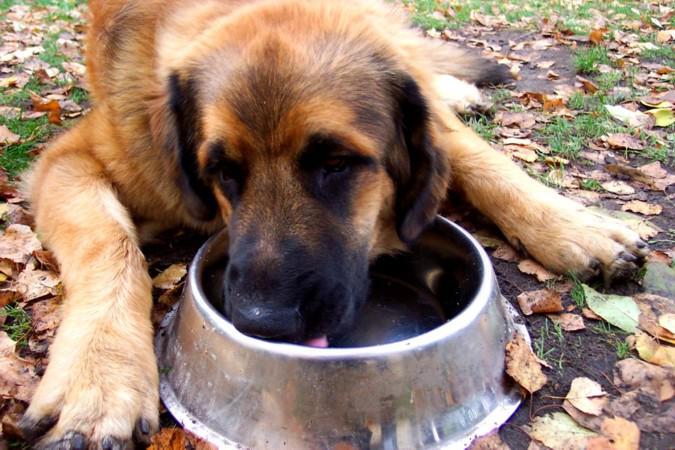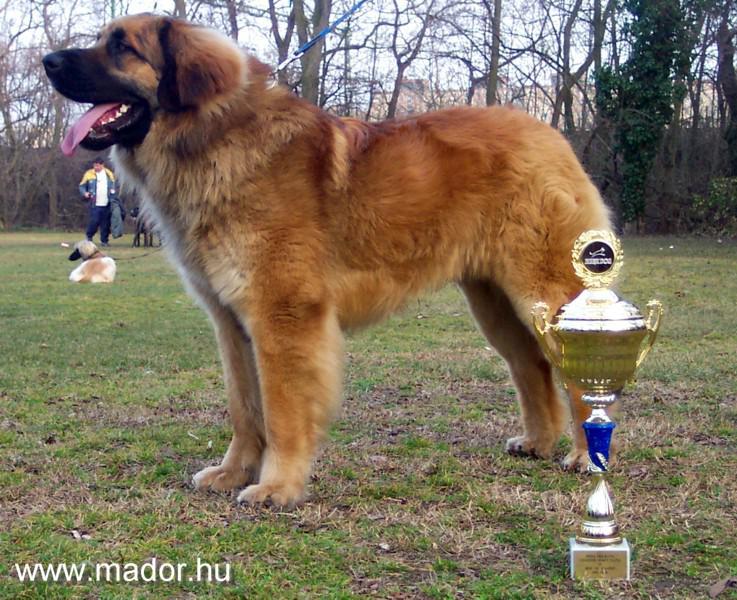The first image is the image on the left, the second image is the image on the right. For the images shown, is this caption "In one of the images there is a large dog next to a trophy." true? Answer yes or no. Yes. The first image is the image on the left, the second image is the image on the right. For the images displayed, is the sentence "A trophy stands in the grass next to a dog in one image." factually correct? Answer yes or no. Yes. 